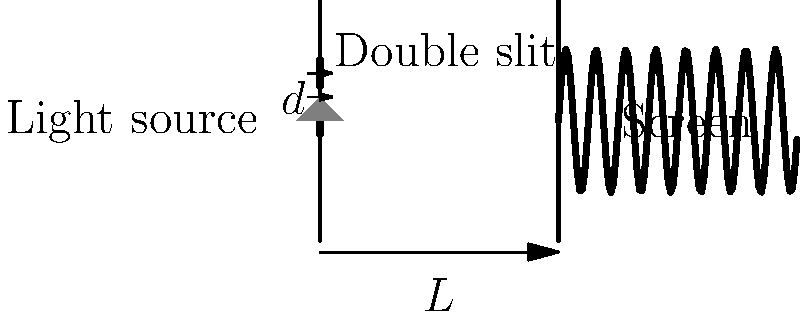In a double-slit experiment, monochromatic light with wavelength $\lambda = 500$ nm is incident on two narrow slits separated by a distance $d = 0.1$ mm. The interference pattern is observed on a screen placed $L = 2$ m away from the slits. What is the distance between two adjacent bright fringes on the screen? How does this relate to the wave-particle duality of light? To solve this problem, we'll use the principle of wave interference and the equation for the double-slit experiment. Let's break it down step-by-step:

1) The equation for the distance $y$ between the central maximum and the $n$th order bright fringe is:

   $$y = \frac{n\lambda L}{d}$$

   where $n$ is the order of the fringe (n = 1, 2, 3, ...), $\lambda$ is the wavelength, $L$ is the distance to the screen, and $d$ is the slit separation.

2) We want the distance between adjacent bright fringes, which means we need to find the difference between $y$ for $n$ and $n+1$:

   $$\Delta y = y_{n+1} - y_n = \frac{(n+1)\lambda L}{d} - \frac{n\lambda L}{d} = \frac{\lambda L}{d}$$

3) Now, let's plug in our values:
   $\lambda = 500 \text{ nm} = 5 \times 10^{-7} \text{ m}$
   $L = 2 \text{ m}$
   $d = 0.1 \text{ mm} = 1 \times 10^{-4} \text{ m}$

   $$\Delta y = \frac{(5 \times 10^{-7})(2)}{1 \times 10^{-4}} = 0.01 \text{ m} = 1 \text{ cm}$$

4) Regarding wave-particle duality:
   This experiment demonstrates the wave nature of light through interference. The light behaves as a wave when passing through the slits, creating an interference pattern. However, when the light hits the screen, it behaves as particles (photons), creating discrete bright spots. This dual behavior is a fundamental aspect of quantum mechanics and illustrates the wave-particle duality of light.
Answer: 1 cm; demonstrates wave behavior through interference and particle behavior upon detection. 